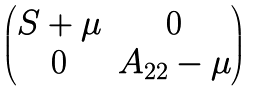<formula> <loc_0><loc_0><loc_500><loc_500>\begin{pmatrix} S + \mu & 0 \\ 0 & A _ { 2 2 } - \mu \end{pmatrix}</formula> 